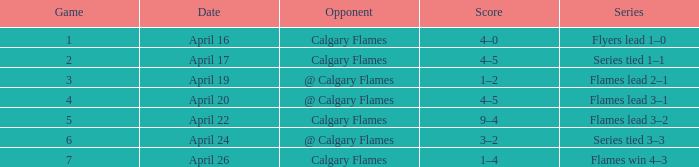Which Date has a Game smaller than 4, and an Opponent of calgary flames, and a Score of 4–5? April 17. Help me parse the entirety of this table. {'header': ['Game', 'Date', 'Opponent', 'Score', 'Series'], 'rows': [['1', 'April 16', 'Calgary Flames', '4–0', 'Flyers lead 1–0'], ['2', 'April 17', 'Calgary Flames', '4–5', 'Series tied 1–1'], ['3', 'April 19', '@ Calgary Flames', '1–2', 'Flames lead 2–1'], ['4', 'April 20', '@ Calgary Flames', '4–5', 'Flames lead 3–1'], ['5', 'April 22', 'Calgary Flames', '9–4', 'Flames lead 3–2'], ['6', 'April 24', '@ Calgary Flames', '3–2', 'Series tied 3–3'], ['7', 'April 26', 'Calgary Flames', '1–4', 'Flames win 4–3']]} 